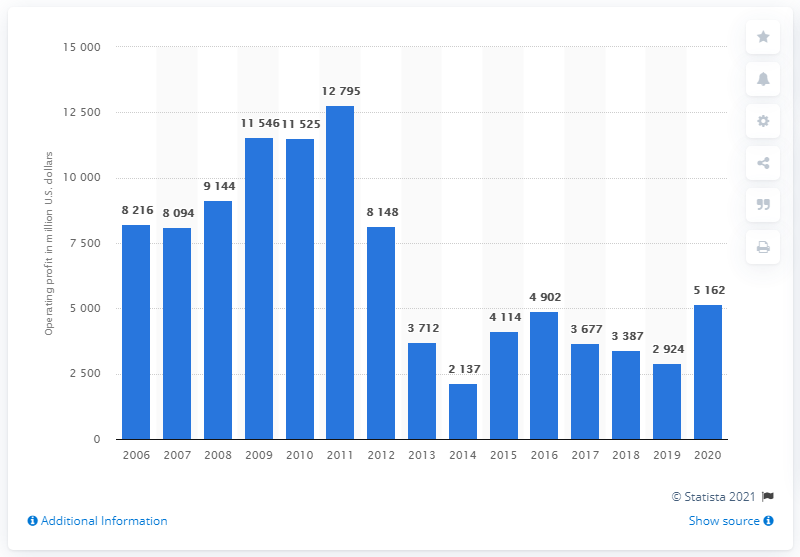Identify some key points in this picture. AstraZeneca's operating profit in 2020 was 51,622. 